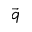<formula> <loc_0><loc_0><loc_500><loc_500>\vec { q }</formula> 